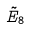<formula> <loc_0><loc_0><loc_500><loc_500>\tilde { E } _ { 8 }</formula> 